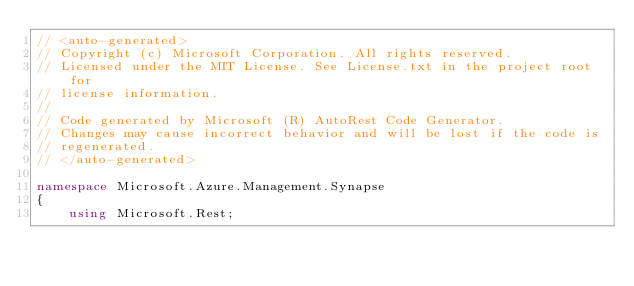Convert code to text. <code><loc_0><loc_0><loc_500><loc_500><_C#_>// <auto-generated>
// Copyright (c) Microsoft Corporation. All rights reserved.
// Licensed under the MIT License. See License.txt in the project root for
// license information.
//
// Code generated by Microsoft (R) AutoRest Code Generator.
// Changes may cause incorrect behavior and will be lost if the code is
// regenerated.
// </auto-generated>

namespace Microsoft.Azure.Management.Synapse
{
    using Microsoft.Rest;</code> 